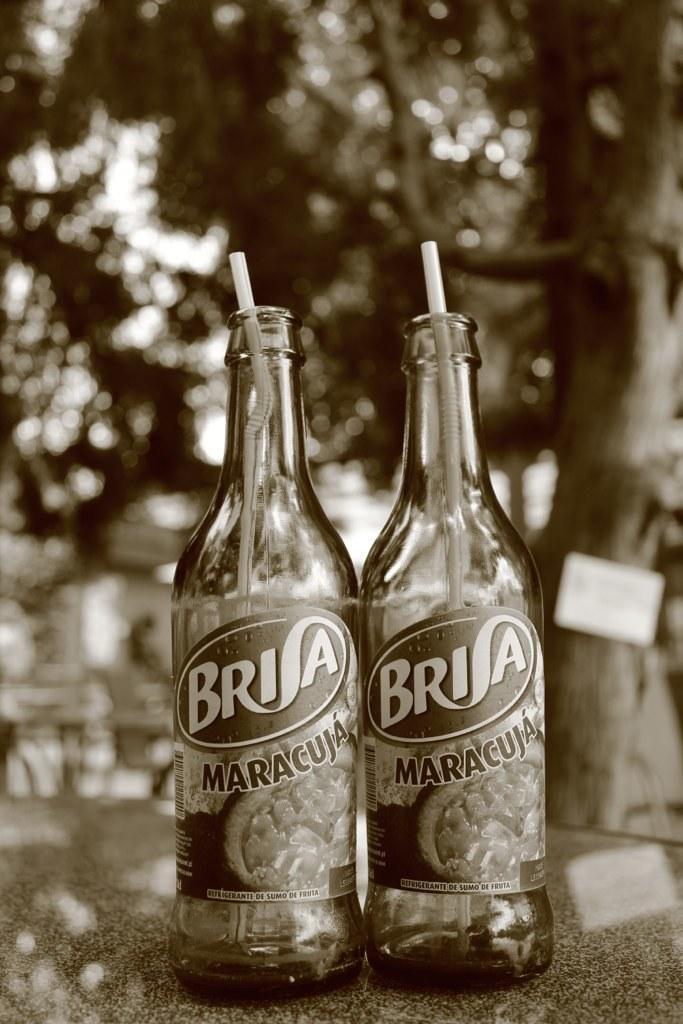Please provide a concise description of this image. In this picture we can see two bottles with the straws. And on the background there are trees. 